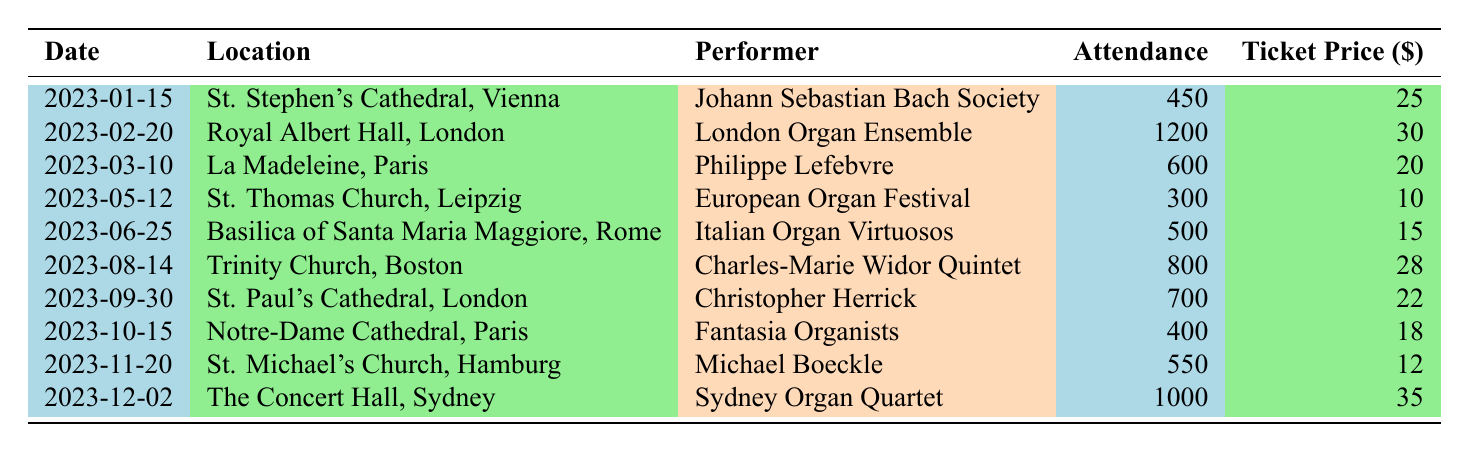What is the highest attendance for an organ concert in 2023? The highest attendance in the table is found by comparing attendance numbers. The maximum attendance is 1200 for the London Organ Ensemble concert on February 20.
Answer: 1200 Which performer appeared at the concert held in Notre-Dame Cathedral, Paris? By looking at the row for the date 2023-10-15, it shows that the performer was the Fantasia Organists.
Answer: Fantasia Organists How much was the ticket price for the concert at St. Thomas Church, Leipzig? The ticket price for the concert on May 12, 2023, at St. Thomas Church is listed directly in the table as 10.
Answer: 10 What was the total attendance for concerts in the months of January and June combined? The attendance for January is 450 and for June is 500. Adding these together gives 450 + 500 = 950.
Answer: 950 Did any concert in 2023 have an attendance of exactly 600? Looking through the attendance figures, there is one concert on March 10, 2023, that had exactly 600 attendees.
Answer: Yes What is the average ticket price for all concerts listed? To find the average, first sum all the ticket prices: 25 + 30 + 20 + 10 + 15 + 28 + 22 + 18 + 12 + 35 =  300. Then divide by the number of concerts, which is 10: 300 / 10 = 30.
Answer: 30 Which concert had the lowest attendance, and what was the attendance number? By reviewing the attendance figures, the concert at St. Thomas Church on May 12 had the lowest attendance with 300.
Answer: 300 Was the ticket price for the concert at Royal Albert Hall higher than for those at St. Michael's Church? The ticket price at Royal Albert Hall is 30, and at St. Michael's Church it is 12. Since 30 is greater than 12, the answer is yes.
Answer: Yes What were the total earnings from ticket sales for the concert held at La Madeleine, Paris? The ticket price at La Madeleine was 20 and the attendance was 600. To find earnings, multiply the ticket price by the attendance: 20 * 600 = 12000.
Answer: 12000 How many concerts took place in Europe in 2023? Reviewing the locations, all concerts except for one in Sydney took place in Europe: Vienna, London, Paris, Leipzig, Rome, and Hamburg. This counts as 9 concerts.
Answer: 9 What is the difference in ticket prices between the concert at Trinity Church, Boston, and the concert at St. Paul's Cathedral, London? The ticket price at Trinity Church is 28 and at St. Paul's Cathedral is 22. To find the difference: 28 - 22 = 6.
Answer: 6 